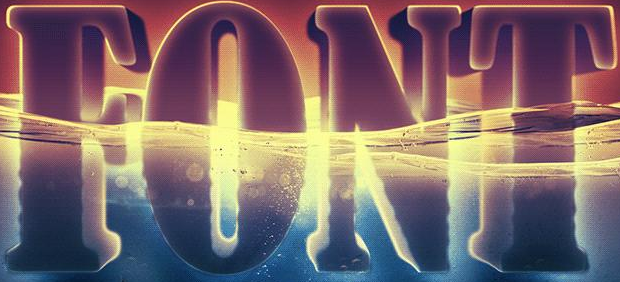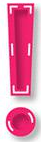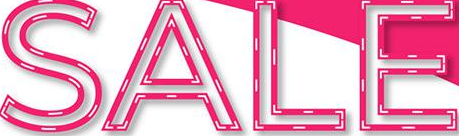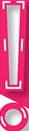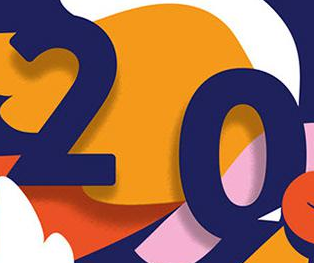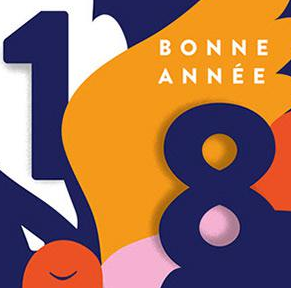Identify the words shown in these images in order, separated by a semicolon. FONT; !; SALE; !; 20; 18 